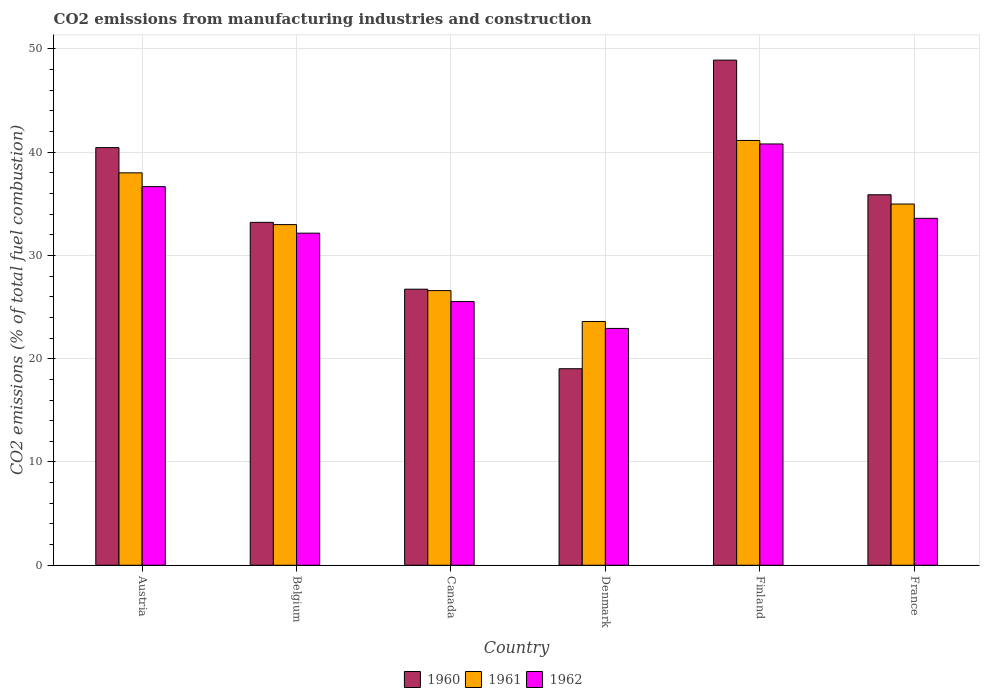Are the number of bars per tick equal to the number of legend labels?
Keep it short and to the point. Yes. Are the number of bars on each tick of the X-axis equal?
Provide a short and direct response. Yes. How many bars are there on the 6th tick from the left?
Offer a terse response. 3. How many bars are there on the 4th tick from the right?
Make the answer very short. 3. What is the amount of CO2 emitted in 1962 in Denmark?
Provide a succinct answer. 22.93. Across all countries, what is the maximum amount of CO2 emitted in 1962?
Ensure brevity in your answer.  40.79. Across all countries, what is the minimum amount of CO2 emitted in 1962?
Your answer should be compact. 22.93. In which country was the amount of CO2 emitted in 1961 maximum?
Give a very brief answer. Finland. What is the total amount of CO2 emitted in 1961 in the graph?
Ensure brevity in your answer.  197.28. What is the difference between the amount of CO2 emitted in 1962 in Finland and that in France?
Provide a short and direct response. 7.2. What is the difference between the amount of CO2 emitted in 1962 in Belgium and the amount of CO2 emitted in 1960 in Canada?
Your response must be concise. 5.43. What is the average amount of CO2 emitted in 1961 per country?
Give a very brief answer. 32.88. What is the difference between the amount of CO2 emitted of/in 1961 and amount of CO2 emitted of/in 1960 in Canada?
Make the answer very short. -0.14. What is the ratio of the amount of CO2 emitted in 1961 in Belgium to that in Canada?
Provide a succinct answer. 1.24. Is the difference between the amount of CO2 emitted in 1961 in Denmark and Finland greater than the difference between the amount of CO2 emitted in 1960 in Denmark and Finland?
Your answer should be very brief. Yes. What is the difference between the highest and the second highest amount of CO2 emitted in 1962?
Offer a very short reply. 7.2. What is the difference between the highest and the lowest amount of CO2 emitted in 1960?
Your answer should be compact. 29.88. What does the 1st bar from the left in Austria represents?
Your answer should be very brief. 1960. What does the 2nd bar from the right in Denmark represents?
Ensure brevity in your answer.  1961. How many countries are there in the graph?
Offer a terse response. 6. Where does the legend appear in the graph?
Your response must be concise. Bottom center. How many legend labels are there?
Make the answer very short. 3. What is the title of the graph?
Offer a terse response. CO2 emissions from manufacturing industries and construction. Does "1986" appear as one of the legend labels in the graph?
Your answer should be very brief. No. What is the label or title of the X-axis?
Provide a succinct answer. Country. What is the label or title of the Y-axis?
Offer a very short reply. CO2 emissions (% of total fuel combustion). What is the CO2 emissions (% of total fuel combustion) of 1960 in Austria?
Ensure brevity in your answer.  40.44. What is the CO2 emissions (% of total fuel combustion) of 1961 in Austria?
Provide a succinct answer. 37.99. What is the CO2 emissions (% of total fuel combustion) in 1962 in Austria?
Give a very brief answer. 36.66. What is the CO2 emissions (% of total fuel combustion) in 1960 in Belgium?
Provide a succinct answer. 33.2. What is the CO2 emissions (% of total fuel combustion) of 1961 in Belgium?
Provide a short and direct response. 32.98. What is the CO2 emissions (% of total fuel combustion) in 1962 in Belgium?
Your answer should be compact. 32.16. What is the CO2 emissions (% of total fuel combustion) of 1960 in Canada?
Give a very brief answer. 26.73. What is the CO2 emissions (% of total fuel combustion) in 1961 in Canada?
Make the answer very short. 26.59. What is the CO2 emissions (% of total fuel combustion) of 1962 in Canada?
Offer a terse response. 25.53. What is the CO2 emissions (% of total fuel combustion) in 1960 in Denmark?
Give a very brief answer. 19.03. What is the CO2 emissions (% of total fuel combustion) of 1961 in Denmark?
Offer a terse response. 23.6. What is the CO2 emissions (% of total fuel combustion) in 1962 in Denmark?
Provide a short and direct response. 22.93. What is the CO2 emissions (% of total fuel combustion) in 1960 in Finland?
Your answer should be very brief. 48.91. What is the CO2 emissions (% of total fuel combustion) in 1961 in Finland?
Your answer should be very brief. 41.13. What is the CO2 emissions (% of total fuel combustion) in 1962 in Finland?
Offer a very short reply. 40.79. What is the CO2 emissions (% of total fuel combustion) in 1960 in France?
Your response must be concise. 35.87. What is the CO2 emissions (% of total fuel combustion) of 1961 in France?
Your response must be concise. 34.98. What is the CO2 emissions (% of total fuel combustion) of 1962 in France?
Your answer should be very brief. 33.59. Across all countries, what is the maximum CO2 emissions (% of total fuel combustion) in 1960?
Ensure brevity in your answer.  48.91. Across all countries, what is the maximum CO2 emissions (% of total fuel combustion) of 1961?
Your answer should be compact. 41.13. Across all countries, what is the maximum CO2 emissions (% of total fuel combustion) in 1962?
Give a very brief answer. 40.79. Across all countries, what is the minimum CO2 emissions (% of total fuel combustion) in 1960?
Make the answer very short. 19.03. Across all countries, what is the minimum CO2 emissions (% of total fuel combustion) in 1961?
Your response must be concise. 23.6. Across all countries, what is the minimum CO2 emissions (% of total fuel combustion) of 1962?
Offer a very short reply. 22.93. What is the total CO2 emissions (% of total fuel combustion) of 1960 in the graph?
Your response must be concise. 204.18. What is the total CO2 emissions (% of total fuel combustion) of 1961 in the graph?
Offer a terse response. 197.28. What is the total CO2 emissions (% of total fuel combustion) of 1962 in the graph?
Your answer should be very brief. 191.67. What is the difference between the CO2 emissions (% of total fuel combustion) of 1960 in Austria and that in Belgium?
Your answer should be compact. 7.24. What is the difference between the CO2 emissions (% of total fuel combustion) of 1961 in Austria and that in Belgium?
Ensure brevity in your answer.  5.01. What is the difference between the CO2 emissions (% of total fuel combustion) in 1962 in Austria and that in Belgium?
Keep it short and to the point. 4.51. What is the difference between the CO2 emissions (% of total fuel combustion) in 1960 in Austria and that in Canada?
Make the answer very short. 13.71. What is the difference between the CO2 emissions (% of total fuel combustion) in 1961 in Austria and that in Canada?
Keep it short and to the point. 11.4. What is the difference between the CO2 emissions (% of total fuel combustion) of 1962 in Austria and that in Canada?
Ensure brevity in your answer.  11.13. What is the difference between the CO2 emissions (% of total fuel combustion) in 1960 in Austria and that in Denmark?
Your response must be concise. 21.41. What is the difference between the CO2 emissions (% of total fuel combustion) of 1961 in Austria and that in Denmark?
Provide a short and direct response. 14.39. What is the difference between the CO2 emissions (% of total fuel combustion) of 1962 in Austria and that in Denmark?
Your answer should be very brief. 13.73. What is the difference between the CO2 emissions (% of total fuel combustion) in 1960 in Austria and that in Finland?
Your answer should be compact. -8.47. What is the difference between the CO2 emissions (% of total fuel combustion) in 1961 in Austria and that in Finland?
Make the answer very short. -3.14. What is the difference between the CO2 emissions (% of total fuel combustion) of 1962 in Austria and that in Finland?
Ensure brevity in your answer.  -4.13. What is the difference between the CO2 emissions (% of total fuel combustion) in 1960 in Austria and that in France?
Offer a terse response. 4.57. What is the difference between the CO2 emissions (% of total fuel combustion) of 1961 in Austria and that in France?
Give a very brief answer. 3.02. What is the difference between the CO2 emissions (% of total fuel combustion) of 1962 in Austria and that in France?
Provide a short and direct response. 3.07. What is the difference between the CO2 emissions (% of total fuel combustion) in 1960 in Belgium and that in Canada?
Provide a short and direct response. 6.47. What is the difference between the CO2 emissions (% of total fuel combustion) in 1961 in Belgium and that in Canada?
Provide a short and direct response. 6.39. What is the difference between the CO2 emissions (% of total fuel combustion) in 1962 in Belgium and that in Canada?
Your answer should be very brief. 6.62. What is the difference between the CO2 emissions (% of total fuel combustion) in 1960 in Belgium and that in Denmark?
Ensure brevity in your answer.  14.17. What is the difference between the CO2 emissions (% of total fuel combustion) of 1961 in Belgium and that in Denmark?
Provide a short and direct response. 9.38. What is the difference between the CO2 emissions (% of total fuel combustion) of 1962 in Belgium and that in Denmark?
Your response must be concise. 9.23. What is the difference between the CO2 emissions (% of total fuel combustion) in 1960 in Belgium and that in Finland?
Make the answer very short. -15.71. What is the difference between the CO2 emissions (% of total fuel combustion) of 1961 in Belgium and that in Finland?
Your response must be concise. -8.15. What is the difference between the CO2 emissions (% of total fuel combustion) of 1962 in Belgium and that in Finland?
Keep it short and to the point. -8.64. What is the difference between the CO2 emissions (% of total fuel combustion) of 1960 in Belgium and that in France?
Offer a terse response. -2.67. What is the difference between the CO2 emissions (% of total fuel combustion) in 1961 in Belgium and that in France?
Provide a succinct answer. -1.99. What is the difference between the CO2 emissions (% of total fuel combustion) in 1962 in Belgium and that in France?
Keep it short and to the point. -1.44. What is the difference between the CO2 emissions (% of total fuel combustion) in 1960 in Canada and that in Denmark?
Provide a succinct answer. 7.7. What is the difference between the CO2 emissions (% of total fuel combustion) in 1961 in Canada and that in Denmark?
Offer a very short reply. 2.99. What is the difference between the CO2 emissions (% of total fuel combustion) of 1962 in Canada and that in Denmark?
Give a very brief answer. 2.6. What is the difference between the CO2 emissions (% of total fuel combustion) of 1960 in Canada and that in Finland?
Your response must be concise. -22.18. What is the difference between the CO2 emissions (% of total fuel combustion) in 1961 in Canada and that in Finland?
Your response must be concise. -14.54. What is the difference between the CO2 emissions (% of total fuel combustion) in 1962 in Canada and that in Finland?
Keep it short and to the point. -15.26. What is the difference between the CO2 emissions (% of total fuel combustion) in 1960 in Canada and that in France?
Provide a succinct answer. -9.14. What is the difference between the CO2 emissions (% of total fuel combustion) of 1961 in Canada and that in France?
Provide a succinct answer. -8.38. What is the difference between the CO2 emissions (% of total fuel combustion) in 1962 in Canada and that in France?
Keep it short and to the point. -8.06. What is the difference between the CO2 emissions (% of total fuel combustion) of 1960 in Denmark and that in Finland?
Make the answer very short. -29.88. What is the difference between the CO2 emissions (% of total fuel combustion) in 1961 in Denmark and that in Finland?
Offer a very short reply. -17.53. What is the difference between the CO2 emissions (% of total fuel combustion) of 1962 in Denmark and that in Finland?
Your answer should be very brief. -17.86. What is the difference between the CO2 emissions (% of total fuel combustion) in 1960 in Denmark and that in France?
Give a very brief answer. -16.84. What is the difference between the CO2 emissions (% of total fuel combustion) of 1961 in Denmark and that in France?
Offer a terse response. -11.37. What is the difference between the CO2 emissions (% of total fuel combustion) in 1962 in Denmark and that in France?
Make the answer very short. -10.66. What is the difference between the CO2 emissions (% of total fuel combustion) in 1960 in Finland and that in France?
Ensure brevity in your answer.  13.04. What is the difference between the CO2 emissions (% of total fuel combustion) in 1961 in Finland and that in France?
Provide a short and direct response. 6.16. What is the difference between the CO2 emissions (% of total fuel combustion) of 1962 in Finland and that in France?
Offer a very short reply. 7.2. What is the difference between the CO2 emissions (% of total fuel combustion) in 1960 in Austria and the CO2 emissions (% of total fuel combustion) in 1961 in Belgium?
Your response must be concise. 7.46. What is the difference between the CO2 emissions (% of total fuel combustion) in 1960 in Austria and the CO2 emissions (% of total fuel combustion) in 1962 in Belgium?
Give a very brief answer. 8.28. What is the difference between the CO2 emissions (% of total fuel combustion) of 1961 in Austria and the CO2 emissions (% of total fuel combustion) of 1962 in Belgium?
Offer a terse response. 5.84. What is the difference between the CO2 emissions (% of total fuel combustion) in 1960 in Austria and the CO2 emissions (% of total fuel combustion) in 1961 in Canada?
Keep it short and to the point. 13.84. What is the difference between the CO2 emissions (% of total fuel combustion) in 1960 in Austria and the CO2 emissions (% of total fuel combustion) in 1962 in Canada?
Give a very brief answer. 14.91. What is the difference between the CO2 emissions (% of total fuel combustion) of 1961 in Austria and the CO2 emissions (% of total fuel combustion) of 1962 in Canada?
Offer a terse response. 12.46. What is the difference between the CO2 emissions (% of total fuel combustion) of 1960 in Austria and the CO2 emissions (% of total fuel combustion) of 1961 in Denmark?
Make the answer very short. 16.84. What is the difference between the CO2 emissions (% of total fuel combustion) of 1960 in Austria and the CO2 emissions (% of total fuel combustion) of 1962 in Denmark?
Make the answer very short. 17.51. What is the difference between the CO2 emissions (% of total fuel combustion) of 1961 in Austria and the CO2 emissions (% of total fuel combustion) of 1962 in Denmark?
Give a very brief answer. 15.06. What is the difference between the CO2 emissions (% of total fuel combustion) in 1960 in Austria and the CO2 emissions (% of total fuel combustion) in 1961 in Finland?
Ensure brevity in your answer.  -0.69. What is the difference between the CO2 emissions (% of total fuel combustion) in 1960 in Austria and the CO2 emissions (% of total fuel combustion) in 1962 in Finland?
Give a very brief answer. -0.35. What is the difference between the CO2 emissions (% of total fuel combustion) of 1961 in Austria and the CO2 emissions (% of total fuel combustion) of 1962 in Finland?
Give a very brief answer. -2.8. What is the difference between the CO2 emissions (% of total fuel combustion) in 1960 in Austria and the CO2 emissions (% of total fuel combustion) in 1961 in France?
Provide a short and direct response. 5.46. What is the difference between the CO2 emissions (% of total fuel combustion) in 1960 in Austria and the CO2 emissions (% of total fuel combustion) in 1962 in France?
Your response must be concise. 6.85. What is the difference between the CO2 emissions (% of total fuel combustion) in 1961 in Austria and the CO2 emissions (% of total fuel combustion) in 1962 in France?
Offer a terse response. 4.4. What is the difference between the CO2 emissions (% of total fuel combustion) in 1960 in Belgium and the CO2 emissions (% of total fuel combustion) in 1961 in Canada?
Offer a terse response. 6.61. What is the difference between the CO2 emissions (% of total fuel combustion) of 1960 in Belgium and the CO2 emissions (% of total fuel combustion) of 1962 in Canada?
Offer a very short reply. 7.67. What is the difference between the CO2 emissions (% of total fuel combustion) in 1961 in Belgium and the CO2 emissions (% of total fuel combustion) in 1962 in Canada?
Provide a succinct answer. 7.45. What is the difference between the CO2 emissions (% of total fuel combustion) of 1960 in Belgium and the CO2 emissions (% of total fuel combustion) of 1961 in Denmark?
Keep it short and to the point. 9.6. What is the difference between the CO2 emissions (% of total fuel combustion) in 1960 in Belgium and the CO2 emissions (% of total fuel combustion) in 1962 in Denmark?
Provide a short and direct response. 10.27. What is the difference between the CO2 emissions (% of total fuel combustion) of 1961 in Belgium and the CO2 emissions (% of total fuel combustion) of 1962 in Denmark?
Provide a succinct answer. 10.05. What is the difference between the CO2 emissions (% of total fuel combustion) in 1960 in Belgium and the CO2 emissions (% of total fuel combustion) in 1961 in Finland?
Keep it short and to the point. -7.93. What is the difference between the CO2 emissions (% of total fuel combustion) of 1960 in Belgium and the CO2 emissions (% of total fuel combustion) of 1962 in Finland?
Offer a terse response. -7.59. What is the difference between the CO2 emissions (% of total fuel combustion) in 1961 in Belgium and the CO2 emissions (% of total fuel combustion) in 1962 in Finland?
Your answer should be compact. -7.81. What is the difference between the CO2 emissions (% of total fuel combustion) of 1960 in Belgium and the CO2 emissions (% of total fuel combustion) of 1961 in France?
Provide a succinct answer. -1.77. What is the difference between the CO2 emissions (% of total fuel combustion) of 1960 in Belgium and the CO2 emissions (% of total fuel combustion) of 1962 in France?
Make the answer very short. -0.39. What is the difference between the CO2 emissions (% of total fuel combustion) of 1961 in Belgium and the CO2 emissions (% of total fuel combustion) of 1962 in France?
Your response must be concise. -0.61. What is the difference between the CO2 emissions (% of total fuel combustion) of 1960 in Canada and the CO2 emissions (% of total fuel combustion) of 1961 in Denmark?
Provide a short and direct response. 3.13. What is the difference between the CO2 emissions (% of total fuel combustion) of 1960 in Canada and the CO2 emissions (% of total fuel combustion) of 1962 in Denmark?
Offer a very short reply. 3.8. What is the difference between the CO2 emissions (% of total fuel combustion) of 1961 in Canada and the CO2 emissions (% of total fuel combustion) of 1962 in Denmark?
Your answer should be compact. 3.66. What is the difference between the CO2 emissions (% of total fuel combustion) of 1960 in Canada and the CO2 emissions (% of total fuel combustion) of 1961 in Finland?
Provide a short and direct response. -14.4. What is the difference between the CO2 emissions (% of total fuel combustion) in 1960 in Canada and the CO2 emissions (% of total fuel combustion) in 1962 in Finland?
Your response must be concise. -14.06. What is the difference between the CO2 emissions (% of total fuel combustion) of 1961 in Canada and the CO2 emissions (% of total fuel combustion) of 1962 in Finland?
Your answer should be compact. -14.2. What is the difference between the CO2 emissions (% of total fuel combustion) of 1960 in Canada and the CO2 emissions (% of total fuel combustion) of 1961 in France?
Make the answer very short. -8.24. What is the difference between the CO2 emissions (% of total fuel combustion) of 1960 in Canada and the CO2 emissions (% of total fuel combustion) of 1962 in France?
Offer a terse response. -6.86. What is the difference between the CO2 emissions (% of total fuel combustion) in 1961 in Canada and the CO2 emissions (% of total fuel combustion) in 1962 in France?
Your answer should be very brief. -7. What is the difference between the CO2 emissions (% of total fuel combustion) in 1960 in Denmark and the CO2 emissions (% of total fuel combustion) in 1961 in Finland?
Your answer should be very brief. -22.1. What is the difference between the CO2 emissions (% of total fuel combustion) of 1960 in Denmark and the CO2 emissions (% of total fuel combustion) of 1962 in Finland?
Your answer should be compact. -21.76. What is the difference between the CO2 emissions (% of total fuel combustion) of 1961 in Denmark and the CO2 emissions (% of total fuel combustion) of 1962 in Finland?
Provide a succinct answer. -17.19. What is the difference between the CO2 emissions (% of total fuel combustion) in 1960 in Denmark and the CO2 emissions (% of total fuel combustion) in 1961 in France?
Provide a succinct answer. -15.95. What is the difference between the CO2 emissions (% of total fuel combustion) in 1960 in Denmark and the CO2 emissions (% of total fuel combustion) in 1962 in France?
Provide a succinct answer. -14.56. What is the difference between the CO2 emissions (% of total fuel combustion) of 1961 in Denmark and the CO2 emissions (% of total fuel combustion) of 1962 in France?
Your answer should be compact. -9.99. What is the difference between the CO2 emissions (% of total fuel combustion) of 1960 in Finland and the CO2 emissions (% of total fuel combustion) of 1961 in France?
Offer a terse response. 13.93. What is the difference between the CO2 emissions (% of total fuel combustion) in 1960 in Finland and the CO2 emissions (% of total fuel combustion) in 1962 in France?
Offer a terse response. 15.32. What is the difference between the CO2 emissions (% of total fuel combustion) of 1961 in Finland and the CO2 emissions (% of total fuel combustion) of 1962 in France?
Ensure brevity in your answer.  7.54. What is the average CO2 emissions (% of total fuel combustion) of 1960 per country?
Make the answer very short. 34.03. What is the average CO2 emissions (% of total fuel combustion) in 1961 per country?
Make the answer very short. 32.88. What is the average CO2 emissions (% of total fuel combustion) of 1962 per country?
Your answer should be very brief. 31.94. What is the difference between the CO2 emissions (% of total fuel combustion) in 1960 and CO2 emissions (% of total fuel combustion) in 1961 in Austria?
Provide a short and direct response. 2.44. What is the difference between the CO2 emissions (% of total fuel combustion) of 1960 and CO2 emissions (% of total fuel combustion) of 1962 in Austria?
Your response must be concise. 3.78. What is the difference between the CO2 emissions (% of total fuel combustion) of 1961 and CO2 emissions (% of total fuel combustion) of 1962 in Austria?
Make the answer very short. 1.33. What is the difference between the CO2 emissions (% of total fuel combustion) in 1960 and CO2 emissions (% of total fuel combustion) in 1961 in Belgium?
Give a very brief answer. 0.22. What is the difference between the CO2 emissions (% of total fuel combustion) of 1960 and CO2 emissions (% of total fuel combustion) of 1962 in Belgium?
Ensure brevity in your answer.  1.04. What is the difference between the CO2 emissions (% of total fuel combustion) of 1961 and CO2 emissions (% of total fuel combustion) of 1962 in Belgium?
Your answer should be very brief. 0.83. What is the difference between the CO2 emissions (% of total fuel combustion) in 1960 and CO2 emissions (% of total fuel combustion) in 1961 in Canada?
Provide a short and direct response. 0.14. What is the difference between the CO2 emissions (% of total fuel combustion) of 1960 and CO2 emissions (% of total fuel combustion) of 1962 in Canada?
Offer a terse response. 1.2. What is the difference between the CO2 emissions (% of total fuel combustion) in 1961 and CO2 emissions (% of total fuel combustion) in 1962 in Canada?
Provide a short and direct response. 1.06. What is the difference between the CO2 emissions (% of total fuel combustion) in 1960 and CO2 emissions (% of total fuel combustion) in 1961 in Denmark?
Provide a short and direct response. -4.57. What is the difference between the CO2 emissions (% of total fuel combustion) in 1960 and CO2 emissions (% of total fuel combustion) in 1962 in Denmark?
Give a very brief answer. -3.9. What is the difference between the CO2 emissions (% of total fuel combustion) of 1961 and CO2 emissions (% of total fuel combustion) of 1962 in Denmark?
Your response must be concise. 0.67. What is the difference between the CO2 emissions (% of total fuel combustion) of 1960 and CO2 emissions (% of total fuel combustion) of 1961 in Finland?
Your answer should be very brief. 7.78. What is the difference between the CO2 emissions (% of total fuel combustion) of 1960 and CO2 emissions (% of total fuel combustion) of 1962 in Finland?
Ensure brevity in your answer.  8.12. What is the difference between the CO2 emissions (% of total fuel combustion) in 1961 and CO2 emissions (% of total fuel combustion) in 1962 in Finland?
Your response must be concise. 0.34. What is the difference between the CO2 emissions (% of total fuel combustion) in 1960 and CO2 emissions (% of total fuel combustion) in 1961 in France?
Offer a very short reply. 0.9. What is the difference between the CO2 emissions (% of total fuel combustion) in 1960 and CO2 emissions (% of total fuel combustion) in 1962 in France?
Provide a succinct answer. 2.28. What is the difference between the CO2 emissions (% of total fuel combustion) of 1961 and CO2 emissions (% of total fuel combustion) of 1962 in France?
Your response must be concise. 1.38. What is the ratio of the CO2 emissions (% of total fuel combustion) of 1960 in Austria to that in Belgium?
Your answer should be compact. 1.22. What is the ratio of the CO2 emissions (% of total fuel combustion) in 1961 in Austria to that in Belgium?
Provide a short and direct response. 1.15. What is the ratio of the CO2 emissions (% of total fuel combustion) of 1962 in Austria to that in Belgium?
Give a very brief answer. 1.14. What is the ratio of the CO2 emissions (% of total fuel combustion) in 1960 in Austria to that in Canada?
Provide a short and direct response. 1.51. What is the ratio of the CO2 emissions (% of total fuel combustion) of 1961 in Austria to that in Canada?
Make the answer very short. 1.43. What is the ratio of the CO2 emissions (% of total fuel combustion) of 1962 in Austria to that in Canada?
Provide a short and direct response. 1.44. What is the ratio of the CO2 emissions (% of total fuel combustion) in 1960 in Austria to that in Denmark?
Make the answer very short. 2.13. What is the ratio of the CO2 emissions (% of total fuel combustion) in 1961 in Austria to that in Denmark?
Your answer should be very brief. 1.61. What is the ratio of the CO2 emissions (% of total fuel combustion) of 1962 in Austria to that in Denmark?
Offer a very short reply. 1.6. What is the ratio of the CO2 emissions (% of total fuel combustion) in 1960 in Austria to that in Finland?
Your answer should be very brief. 0.83. What is the ratio of the CO2 emissions (% of total fuel combustion) in 1961 in Austria to that in Finland?
Your answer should be compact. 0.92. What is the ratio of the CO2 emissions (% of total fuel combustion) in 1962 in Austria to that in Finland?
Your answer should be compact. 0.9. What is the ratio of the CO2 emissions (% of total fuel combustion) in 1960 in Austria to that in France?
Ensure brevity in your answer.  1.13. What is the ratio of the CO2 emissions (% of total fuel combustion) in 1961 in Austria to that in France?
Offer a terse response. 1.09. What is the ratio of the CO2 emissions (% of total fuel combustion) of 1962 in Austria to that in France?
Offer a very short reply. 1.09. What is the ratio of the CO2 emissions (% of total fuel combustion) in 1960 in Belgium to that in Canada?
Your response must be concise. 1.24. What is the ratio of the CO2 emissions (% of total fuel combustion) in 1961 in Belgium to that in Canada?
Give a very brief answer. 1.24. What is the ratio of the CO2 emissions (% of total fuel combustion) of 1962 in Belgium to that in Canada?
Offer a very short reply. 1.26. What is the ratio of the CO2 emissions (% of total fuel combustion) of 1960 in Belgium to that in Denmark?
Your answer should be very brief. 1.74. What is the ratio of the CO2 emissions (% of total fuel combustion) of 1961 in Belgium to that in Denmark?
Ensure brevity in your answer.  1.4. What is the ratio of the CO2 emissions (% of total fuel combustion) of 1962 in Belgium to that in Denmark?
Keep it short and to the point. 1.4. What is the ratio of the CO2 emissions (% of total fuel combustion) of 1960 in Belgium to that in Finland?
Offer a very short reply. 0.68. What is the ratio of the CO2 emissions (% of total fuel combustion) in 1961 in Belgium to that in Finland?
Make the answer very short. 0.8. What is the ratio of the CO2 emissions (% of total fuel combustion) in 1962 in Belgium to that in Finland?
Give a very brief answer. 0.79. What is the ratio of the CO2 emissions (% of total fuel combustion) in 1960 in Belgium to that in France?
Give a very brief answer. 0.93. What is the ratio of the CO2 emissions (% of total fuel combustion) in 1961 in Belgium to that in France?
Keep it short and to the point. 0.94. What is the ratio of the CO2 emissions (% of total fuel combustion) in 1962 in Belgium to that in France?
Your response must be concise. 0.96. What is the ratio of the CO2 emissions (% of total fuel combustion) of 1960 in Canada to that in Denmark?
Ensure brevity in your answer.  1.4. What is the ratio of the CO2 emissions (% of total fuel combustion) in 1961 in Canada to that in Denmark?
Offer a terse response. 1.13. What is the ratio of the CO2 emissions (% of total fuel combustion) of 1962 in Canada to that in Denmark?
Your response must be concise. 1.11. What is the ratio of the CO2 emissions (% of total fuel combustion) in 1960 in Canada to that in Finland?
Provide a short and direct response. 0.55. What is the ratio of the CO2 emissions (% of total fuel combustion) of 1961 in Canada to that in Finland?
Provide a short and direct response. 0.65. What is the ratio of the CO2 emissions (% of total fuel combustion) in 1962 in Canada to that in Finland?
Offer a terse response. 0.63. What is the ratio of the CO2 emissions (% of total fuel combustion) of 1960 in Canada to that in France?
Your answer should be very brief. 0.75. What is the ratio of the CO2 emissions (% of total fuel combustion) of 1961 in Canada to that in France?
Ensure brevity in your answer.  0.76. What is the ratio of the CO2 emissions (% of total fuel combustion) of 1962 in Canada to that in France?
Offer a terse response. 0.76. What is the ratio of the CO2 emissions (% of total fuel combustion) in 1960 in Denmark to that in Finland?
Make the answer very short. 0.39. What is the ratio of the CO2 emissions (% of total fuel combustion) in 1961 in Denmark to that in Finland?
Give a very brief answer. 0.57. What is the ratio of the CO2 emissions (% of total fuel combustion) of 1962 in Denmark to that in Finland?
Provide a short and direct response. 0.56. What is the ratio of the CO2 emissions (% of total fuel combustion) in 1960 in Denmark to that in France?
Give a very brief answer. 0.53. What is the ratio of the CO2 emissions (% of total fuel combustion) in 1961 in Denmark to that in France?
Offer a terse response. 0.67. What is the ratio of the CO2 emissions (% of total fuel combustion) in 1962 in Denmark to that in France?
Your answer should be very brief. 0.68. What is the ratio of the CO2 emissions (% of total fuel combustion) of 1960 in Finland to that in France?
Your answer should be compact. 1.36. What is the ratio of the CO2 emissions (% of total fuel combustion) in 1961 in Finland to that in France?
Make the answer very short. 1.18. What is the ratio of the CO2 emissions (% of total fuel combustion) of 1962 in Finland to that in France?
Ensure brevity in your answer.  1.21. What is the difference between the highest and the second highest CO2 emissions (% of total fuel combustion) of 1960?
Provide a short and direct response. 8.47. What is the difference between the highest and the second highest CO2 emissions (% of total fuel combustion) of 1961?
Offer a very short reply. 3.14. What is the difference between the highest and the second highest CO2 emissions (% of total fuel combustion) of 1962?
Offer a terse response. 4.13. What is the difference between the highest and the lowest CO2 emissions (% of total fuel combustion) in 1960?
Make the answer very short. 29.88. What is the difference between the highest and the lowest CO2 emissions (% of total fuel combustion) in 1961?
Your answer should be very brief. 17.53. What is the difference between the highest and the lowest CO2 emissions (% of total fuel combustion) in 1962?
Your response must be concise. 17.86. 